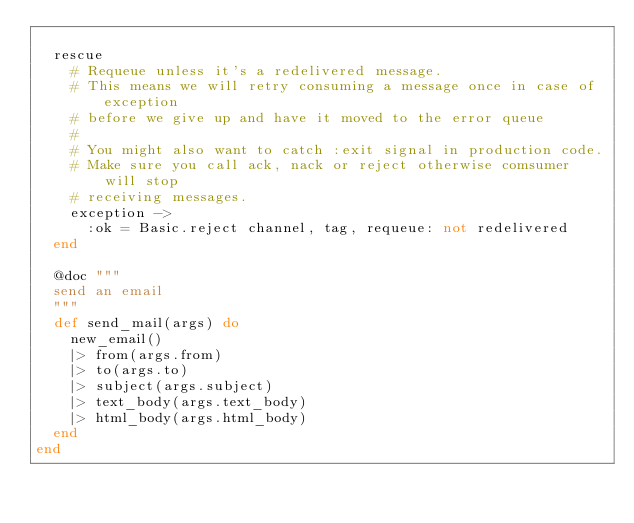Convert code to text. <code><loc_0><loc_0><loc_500><loc_500><_Elixir_>
  rescue
    # Requeue unless it's a redelivered message.
    # This means we will retry consuming a message once in case of exception
    # before we give up and have it moved to the error queue
    #
    # You might also want to catch :exit signal in production code.
    # Make sure you call ack, nack or reject otherwise comsumer will stop
    # receiving messages.
    exception ->
      :ok = Basic.reject channel, tag, requeue: not redelivered
  end

  @doc """
  send an email
  """
  def send_mail(args) do
    new_email()
    |> from(args.from)
    |> to(args.to)
    |> subject(args.subject)
    |> text_body(args.text_body)
    |> html_body(args.html_body)
  end
end
</code> 